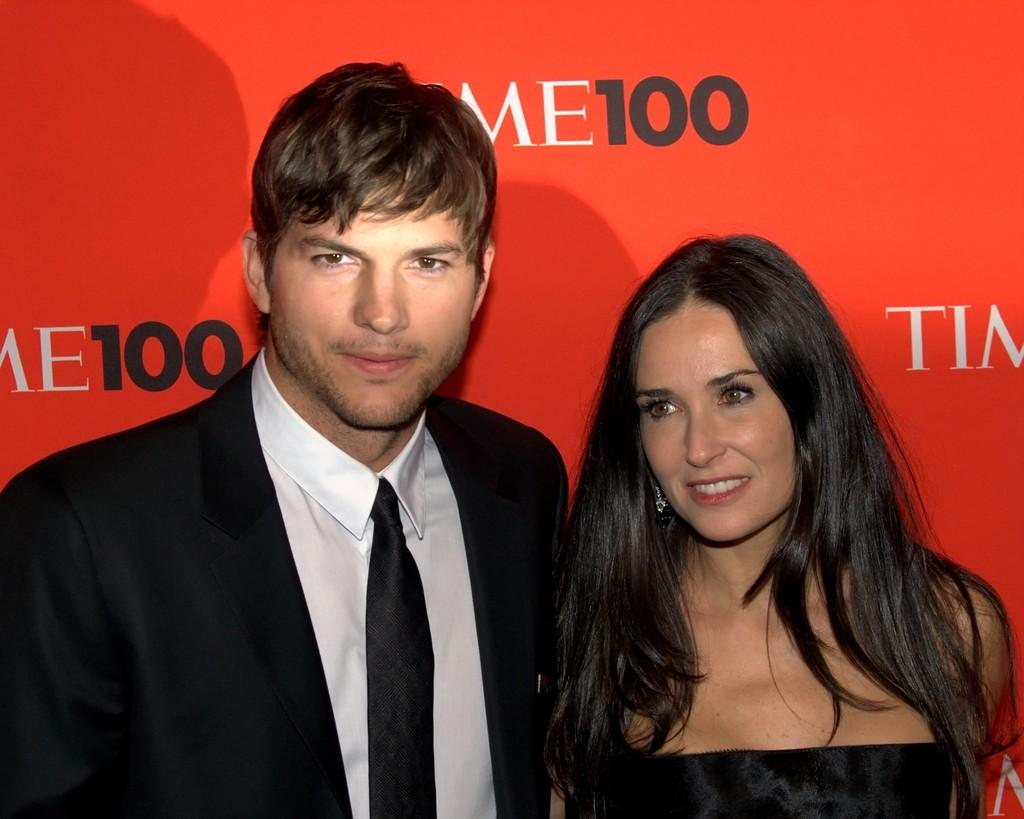Who are the main subjects in the image? There is a couple in the foreground of the image. What is the couple standing in front of? The couple is standing in front of a red banner wall. What type of plane can be seen flying over the couple in the image? There is no plane visible in the image; it only features a couple standing in front of a red banner wall. 